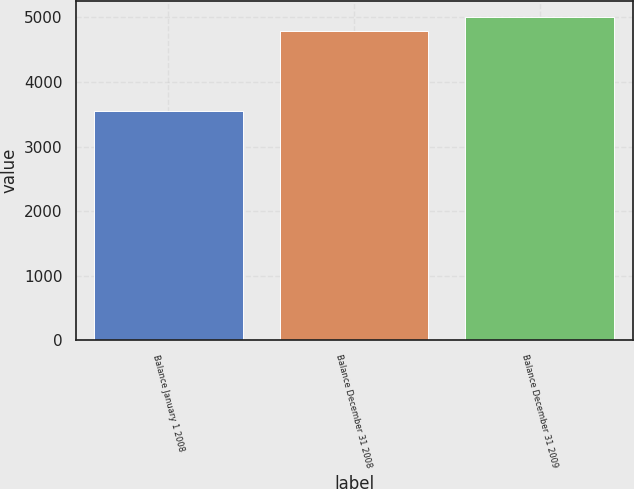<chart> <loc_0><loc_0><loc_500><loc_500><bar_chart><fcel>Balance January 1 2008<fcel>Balance December 31 2008<fcel>Balance December 31 2009<nl><fcel>3549<fcel>4796<fcel>5002<nl></chart> 